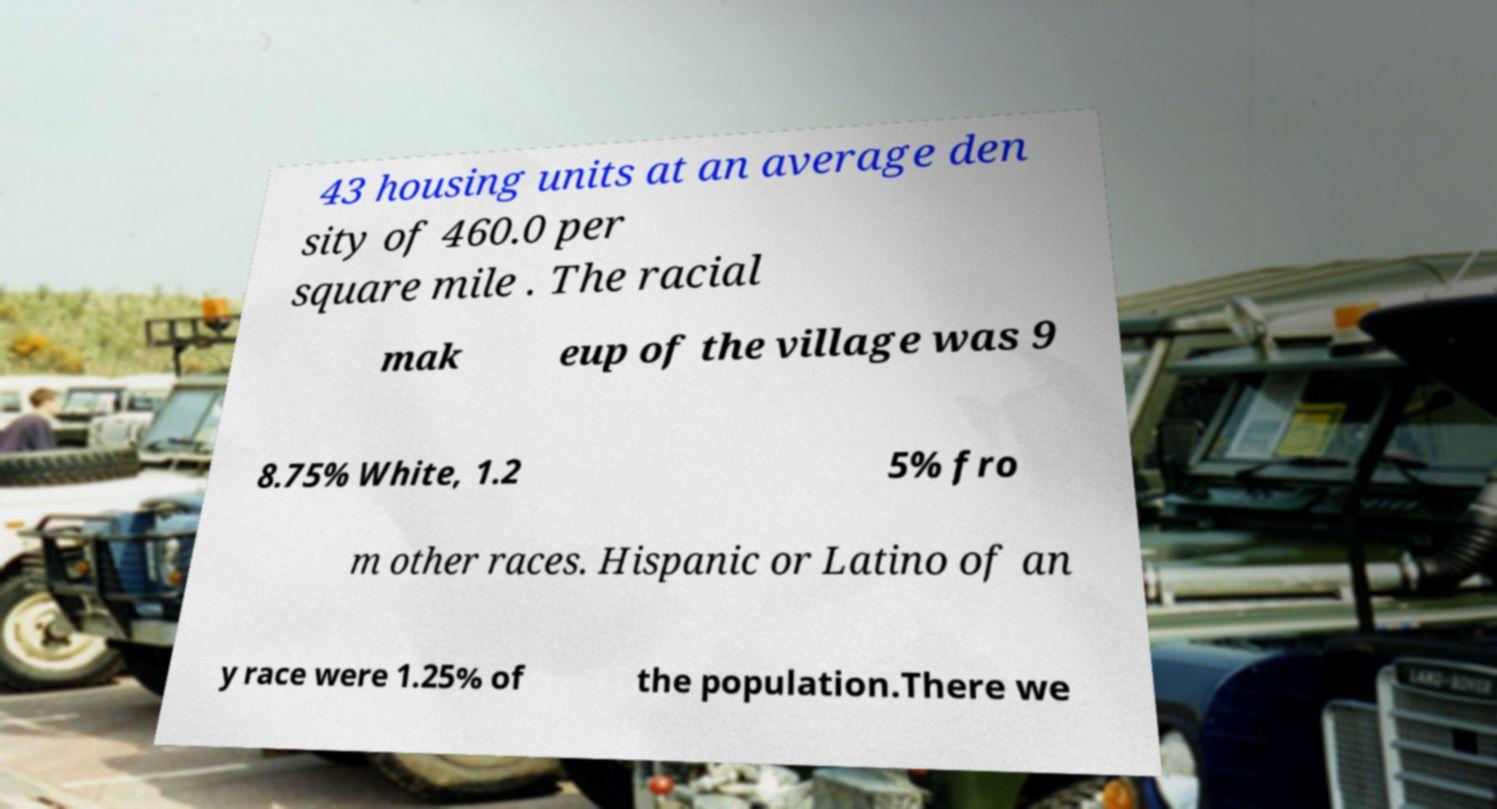Can you accurately transcribe the text from the provided image for me? 43 housing units at an average den sity of 460.0 per square mile . The racial mak eup of the village was 9 8.75% White, 1.2 5% fro m other races. Hispanic or Latino of an y race were 1.25% of the population.There we 